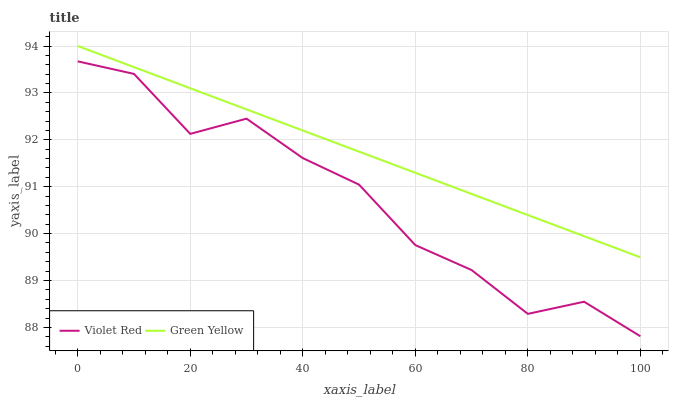Does Violet Red have the minimum area under the curve?
Answer yes or no. Yes. Does Green Yellow have the maximum area under the curve?
Answer yes or no. Yes. Does Green Yellow have the minimum area under the curve?
Answer yes or no. No. Is Green Yellow the smoothest?
Answer yes or no. Yes. Is Violet Red the roughest?
Answer yes or no. Yes. Is Green Yellow the roughest?
Answer yes or no. No. Does Violet Red have the lowest value?
Answer yes or no. Yes. Does Green Yellow have the lowest value?
Answer yes or no. No. Does Green Yellow have the highest value?
Answer yes or no. Yes. Is Violet Red less than Green Yellow?
Answer yes or no. Yes. Is Green Yellow greater than Violet Red?
Answer yes or no. Yes. Does Violet Red intersect Green Yellow?
Answer yes or no. No. 